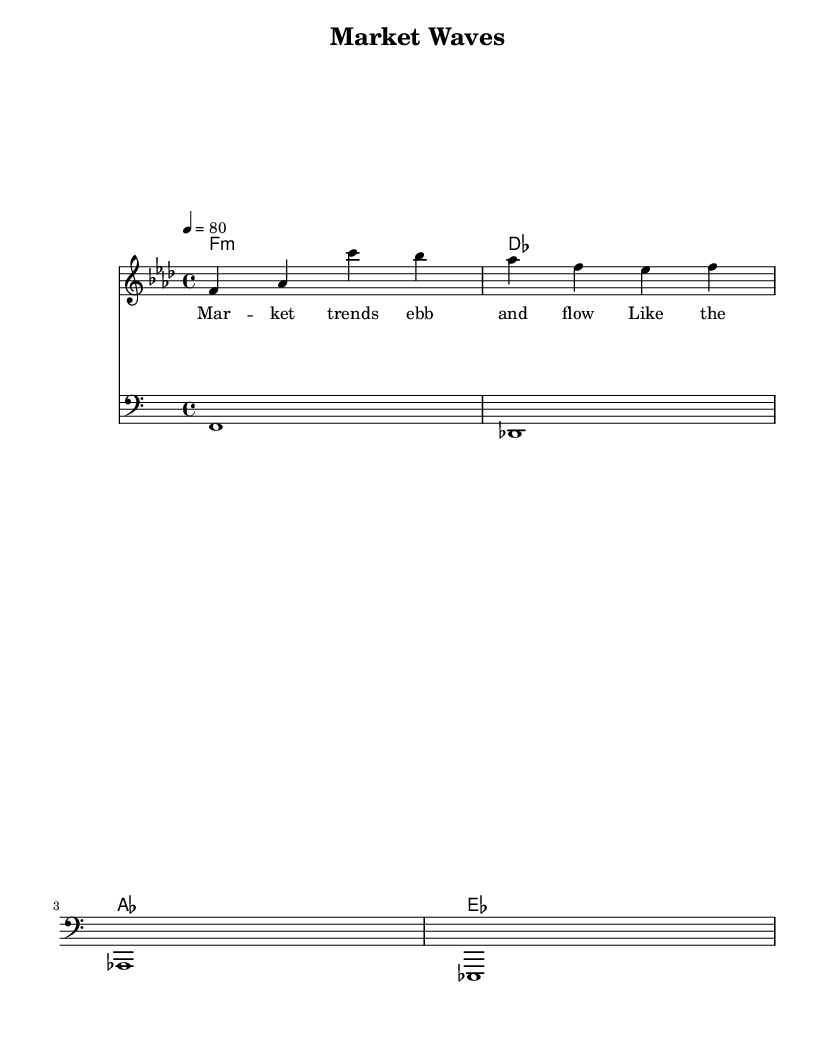What is the key signature of this music? The key signature is indicated by the placement of the flats in the music. In this case, there are four flats, which corresponds to the key of F minor.
Answer: F minor What is the time signature of this piece? The time signature is located at the beginning of the piece, written as a fraction. Here, it shows 4/4 time, indicating four beats per measure.
Answer: 4/4 What is the tempo marking for this music? The tempo is specified in beats per minute, indicated by the number following "tempo." In this piece, it indicates a speed of 80 beats per minute.
Answer: 80 How many measures are in the melody? To find the number of measures, count the separated musical phrases, each representing a measure. There are three measures presented in the melody.
Answer: 3 What is the chord progression used in the harmonies? The harmonies are listed as a series of chords in a specified order. Here, the progression shows f minor, des, aes, and ees, indicating the sequence of chords used.
Answer: f minor, des, aes, ees What type of music is this sheet classified as? The sheet music is labeled with a title that aligns it with a specific genre. Here, the genre is stated as Rhythm and Blues, which reflects the style of music being presented.
Answer: Rhythm and Blues 